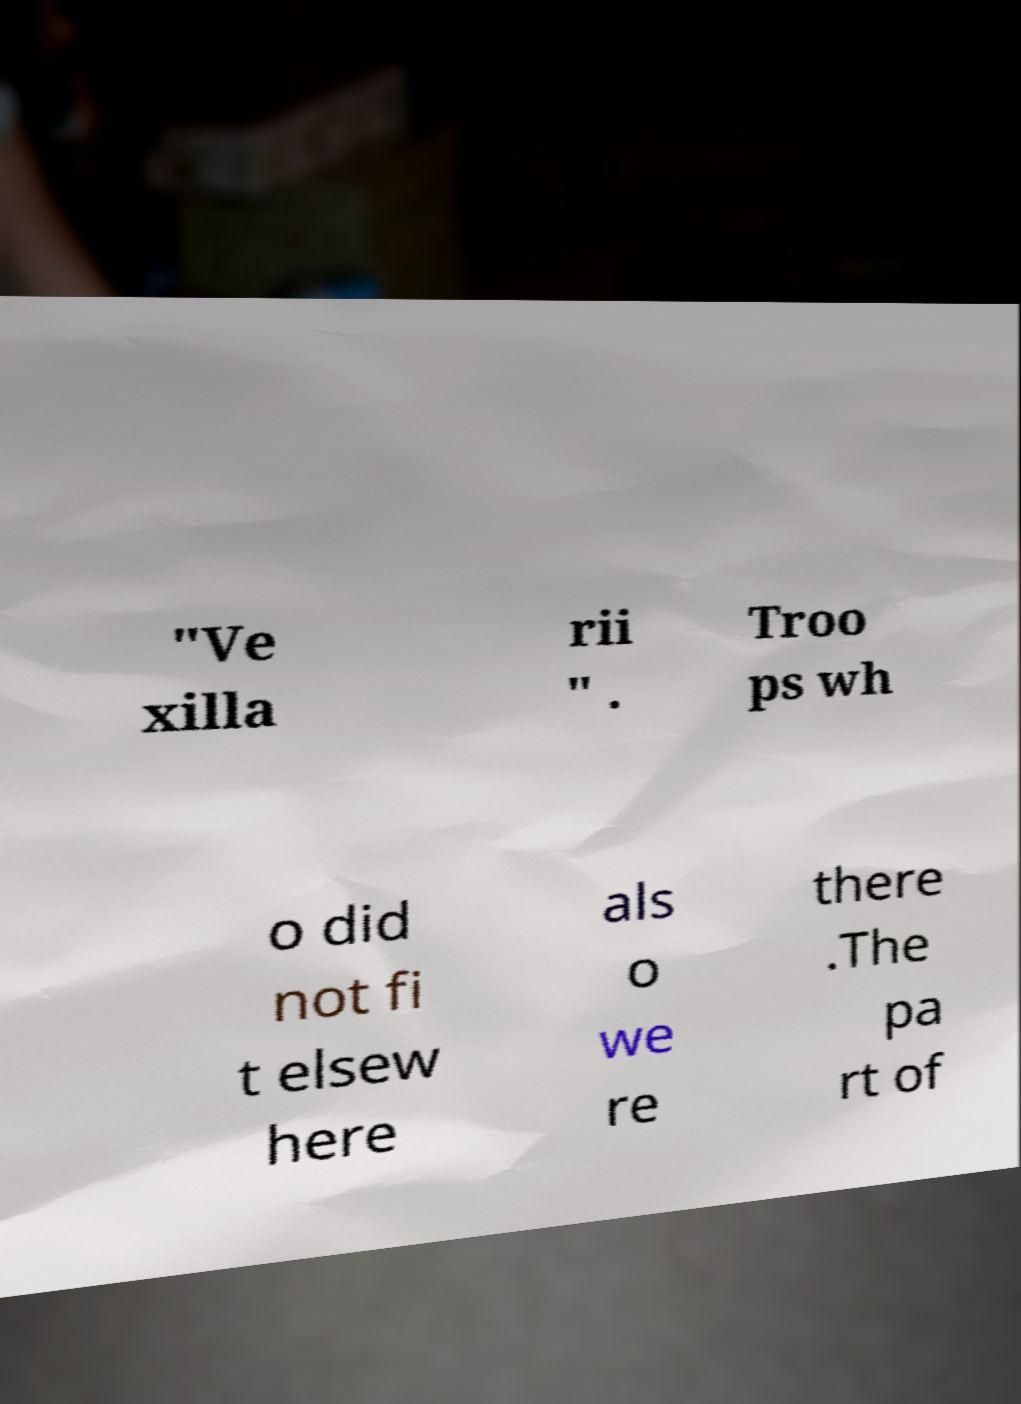For documentation purposes, I need the text within this image transcribed. Could you provide that? "Ve xilla rii " . Troo ps wh o did not fi t elsew here als o we re there .The pa rt of 